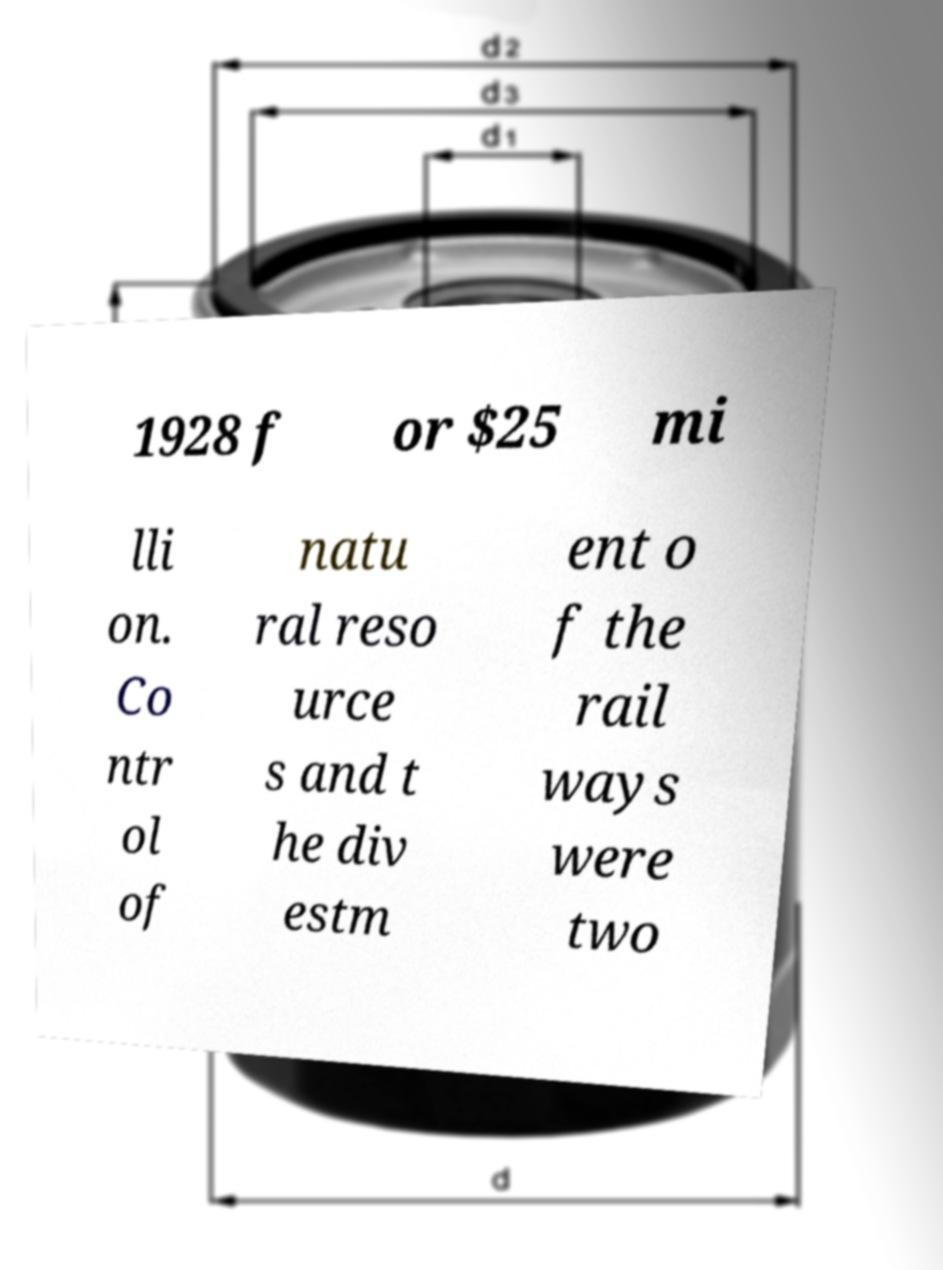There's text embedded in this image that I need extracted. Can you transcribe it verbatim? 1928 f or $25 mi lli on. Co ntr ol of natu ral reso urce s and t he div estm ent o f the rail ways were two 